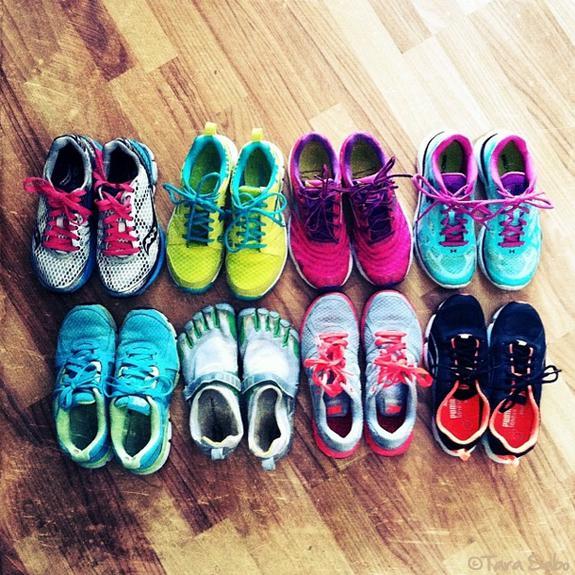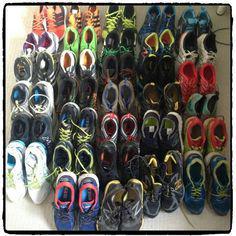The first image is the image on the left, the second image is the image on the right. Considering the images on both sides, is "No more than three sneakers are visible in the left image." valid? Answer yes or no. No. The first image is the image on the left, the second image is the image on the right. Considering the images on both sides, is "One of the images features no more than three shoes." valid? Answer yes or no. No. 